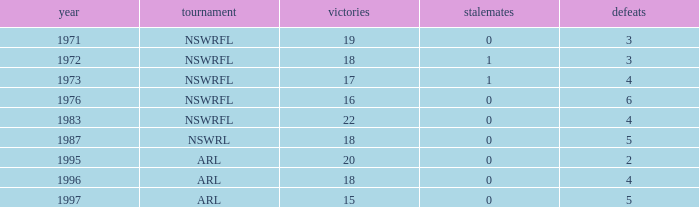What average Wins has Losses 2, and Draws less than 0? None. 